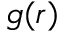<formula> <loc_0><loc_0><loc_500><loc_500>g ( r )</formula> 